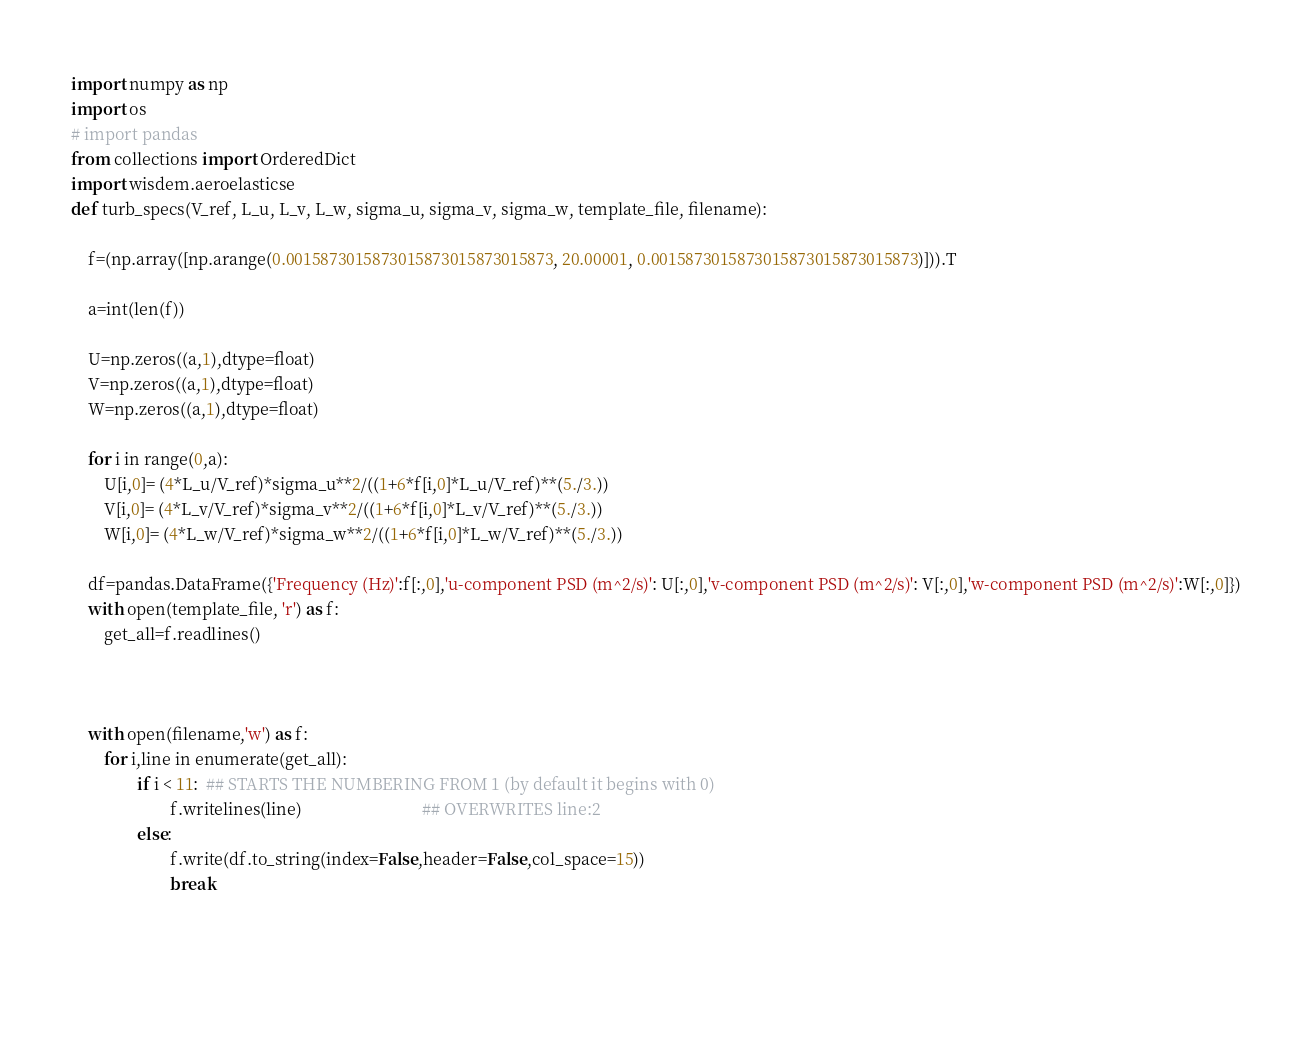<code> <loc_0><loc_0><loc_500><loc_500><_Python_>import numpy as np
import os
# import pandas
from collections import OrderedDict
import wisdem.aeroelasticse
def turb_specs(V_ref, L_u, L_v, L_w, sigma_u, sigma_v, sigma_w, template_file, filename):
    
    f=(np.array([np.arange(0.0015873015873015873015873015873, 20.00001, 0.0015873015873015873015873015873)])).T
    
    a=int(len(f))
    
    U=np.zeros((a,1),dtype=float)
    V=np.zeros((a,1),dtype=float)
    W=np.zeros((a,1),dtype=float)
    
    for i in range(0,a):
        U[i,0]= (4*L_u/V_ref)*sigma_u**2/((1+6*f[i,0]*L_u/V_ref)**(5./3.))
        V[i,0]= (4*L_v/V_ref)*sigma_v**2/((1+6*f[i,0]*L_v/V_ref)**(5./3.))
        W[i,0]= (4*L_w/V_ref)*sigma_w**2/((1+6*f[i,0]*L_w/V_ref)**(5./3.))
        
    df=pandas.DataFrame({'Frequency (Hz)':f[:,0],'u-component PSD (m^2/s)': U[:,0],'v-component PSD (m^2/s)': V[:,0],'w-component PSD (m^2/s)':W[:,0]})
    with open(template_file, 'r') as f:
        get_all=f.readlines() 
    
    
        
    with open(filename,'w') as f:
        for i,line in enumerate(get_all):
                if i < 11:  ## STARTS THE NUMBERING FROM 1 (by default it begins with 0)
                        f.writelines(line)                             ## OVERWRITES line:2
                else: 
                        f.write(df.to_string(index=False,header=False,col_space=15))
                        break
                
                                                                                                               
    

</code> 